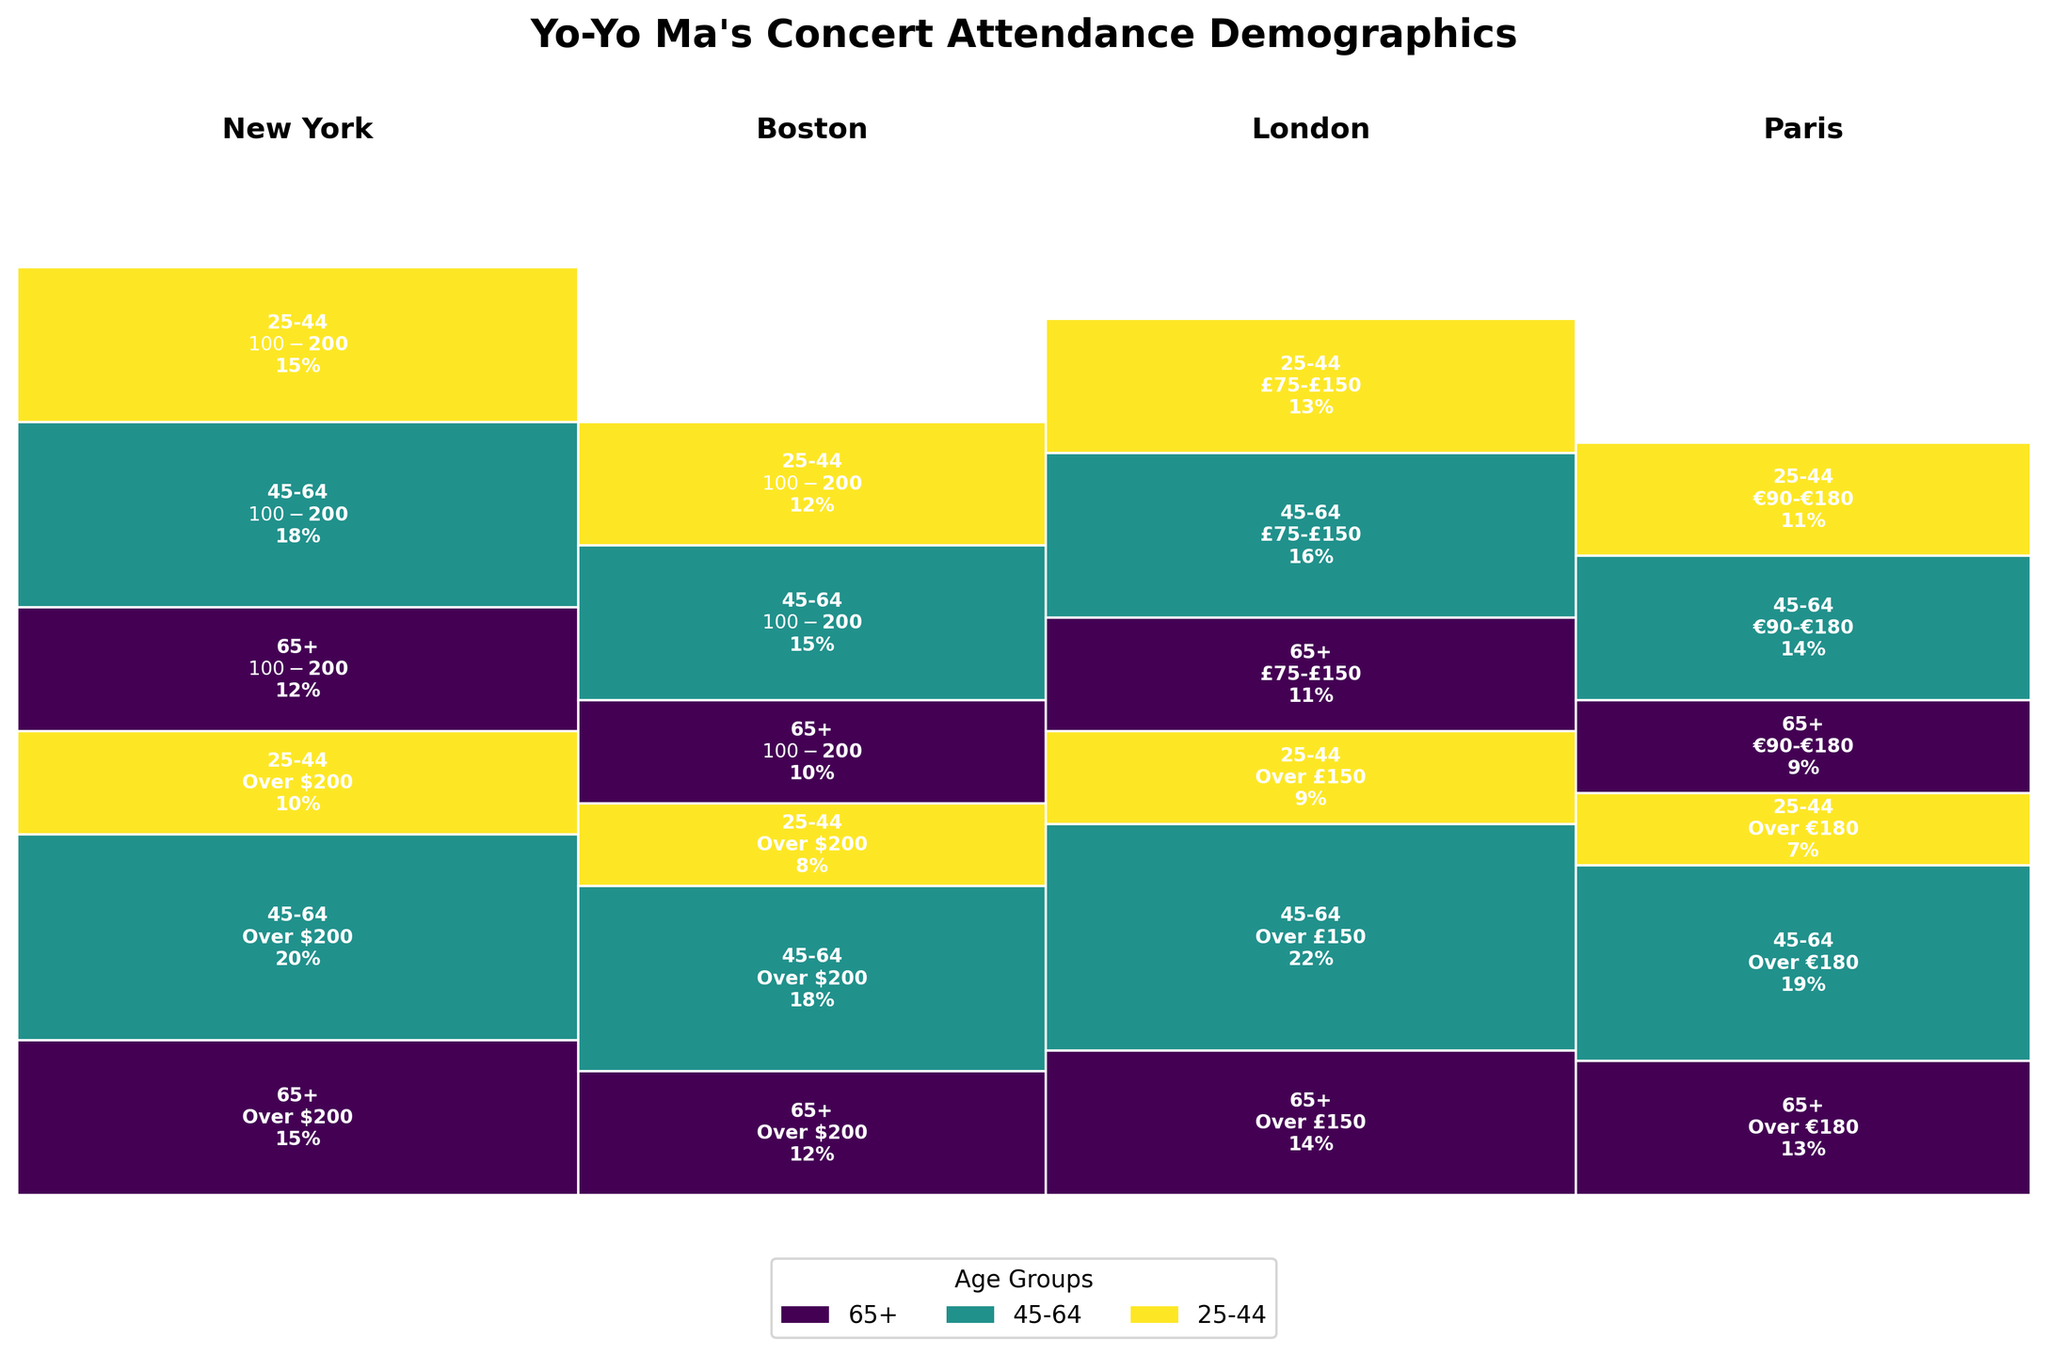What are the age groups represented in the Mosaic Plot? The figure shows distinct color regions labeled with different age groups. These regions are specified in the legend at the bottom and within the labels inside the rectangles.
Answer: 25-44, 45-64, 65+ Which location has the highest percentage of attendees in the price range "Over $200"? By observing the heights of the rectangles within the "Over $200" segments for each location, one can identify the tallest segment.
Answer: New York What is the combined percentage of attendees in the age group 45-64 in Boston across both price ranges? To get the combined percentage, add the heights of the 45-64 segments in the "Over $200" and the "$100-$200" price ranges for Boston. These values are derived from annotations within the rectangles representing this age group and location. (18% + 15%)
Answer: 33% Which price range has higher attendance in Paris, "Over €180" or "€90-€180"? Compare the overall heights of the rectangles representing the two price ranges for Paris. The higher combined height indicates greater attendance.
Answer: Over €180 What percentage of attendees in London belong to the age group 25-44 and paid within the range £75-£150? Locate the London section, then find the rectangle corresponding to the £75-£150 price range and the 25-44 age group. The value inside this rectangle gives the percentage.
Answer: 13% How does the percentage of attendees aged 65+ in Boston's highest price range compare to those in New York's same price range? Examine the annotations within the relevant "Over $200" rectangles for each city's 65+ age group and compare the values given.
Answer: Boston has 3% less than New York (12% compared to 15%) How many price categories are there in the plot for London? Each distinct section (colored differently and labeled by price ranges) within the London section represents a price category. Count these sections.
Answer: 2 What is the total percentage of attendees aged 65+ across all cities? Add the percentages of the 65+ age group in all price ranges for each city. Calculate as follows: (15% + 12% + 12% + 10% + 14% + 11% + 13% + 9%).
Answer: 96% Which city has the lowest representation in the combined age group 25-44, considering all price ranges? Summarize the annotations within all rectangles representing the 25-44 age group across all price ranges for each city. Compare these summed values to find the lowest.
Answer: Paris What is the title of the Mosaic Plot? The title appears at the top of the figure and encapsulates the main idea of the visualization.
Answer: Yo-Yo Ma's Concert Attendance Demographics 